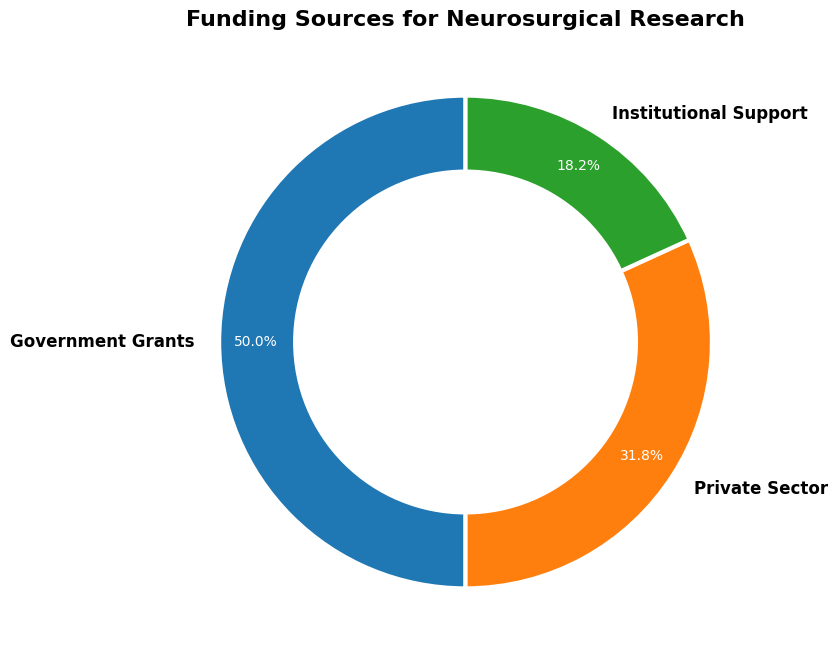What is the total percentage contribution of Government Grants and Private Sector combined? The Government Grants contribute 55.0% and the Private Sector contributes 35.0%. Adding these together, 55.0% + 35.0% equals 90.0%.
Answer: 90.0% Which funding source contributes less, Private Sector or Institutional Support? From the chart, the Private Sector contributes 35.0%, while Institutional Support contributes 20.0%. Since 35.0% is greater than 20.0%, Institutional Support contributes less.
Answer: Institutional Support By what percentage do Government Grants exceed Institutional Support? Government Grants account for 55.0% and Institutional Support for 20.0%. The difference is 55.0% - 20.0% which equals 35.0%.
Answer: 35.0% Which sector has the largest share of funding for neurosurgical research? Government Grants contribute the highest percentage of 55.0% according to the chart.
Answer: Government Grants How much greater is the percentage of Government Grants compared to Private Sector funding? The percentage for Government Grants is 55.0%, and for Private Sector, it is 35.0%. The difference is 55.0% - 35.0% which results in 20.0%.
Answer: 20.0% What is the smallest funding source in terms of percentage? Institutional Support is the smallest funding source, contributing 20.0% as seen on the chart.
Answer: Institutional Support If the total funding amount is increased by 10%, what would be the new percentage contribution of Institutional Support, assuming its absolute amount remains the same? The total current funding amount is $5,500,000 (Government Grants) + $3,500,000 (Private Sector) + $2,000,000 (Institutional Support) = $11,000,000. A 10% increase in total funding results in $11,000,000 * 1.10 = $12,100,000. The new percentage contribution of Institutional Support is ($2,000,000 / $12,100,000) * 100 ≈ 16.5%.
Answer: 16.5% What is the visual indicator used to differentiate each funding source on the ring chart? Each funding source is represented by a different colored segment within the ring chart. The segments are color-coded.
Answer: Color-coded segments If the Institutional Support amount was doubled, what would be the new percentage contributions of all funding sources? The current total is $5,500,000 (Government Grants) + $3,500,000 (Private Sector) + $2,000,000 (Institutional Support) = $11,000,000. Doubling Institutional Support results in $4,000,000. The new total funding is $5,500,000 + $3,500,000 + $4,000,000 = $13,000,000. The new percentages would be: Government Grants: ($5,500,000 / $13,000,000) * 100 ≈ 42.3%, Private Sector: ($3,500,000 / $13,000,000) * 100 ≈ 26.9%, Institutional Support: ($4,000,000 / $13,000,000) * 100 ≈ 30.8%.
Answer: Government Grants: 42.3%, Private Sector: 26.9%, Institutional Support: 30.8% 